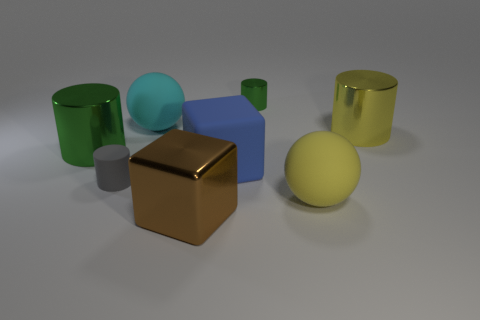What shape is the other object that is the same color as the small metallic object?
Provide a succinct answer. Cylinder. What number of tiny objects are in front of the green cylinder to the right of the big cyan rubber object?
Ensure brevity in your answer.  1. Are there any other things that have the same material as the brown cube?
Your answer should be very brief. Yes. How many objects are either large metal cylinders that are to the left of the large brown shiny cube or yellow metallic things?
Keep it short and to the point. 2. There is a green cylinder that is to the left of the large blue rubber block; what is its size?
Give a very brief answer. Large. What is the material of the brown block?
Provide a short and direct response. Metal. There is a large yellow thing that is on the right side of the large ball to the right of the tiny green object; what is its shape?
Provide a succinct answer. Cylinder. How many other objects are there of the same shape as the big cyan matte object?
Provide a short and direct response. 1. There is a cyan object; are there any cyan things to the right of it?
Your answer should be very brief. No. What is the color of the matte cylinder?
Provide a succinct answer. Gray. 